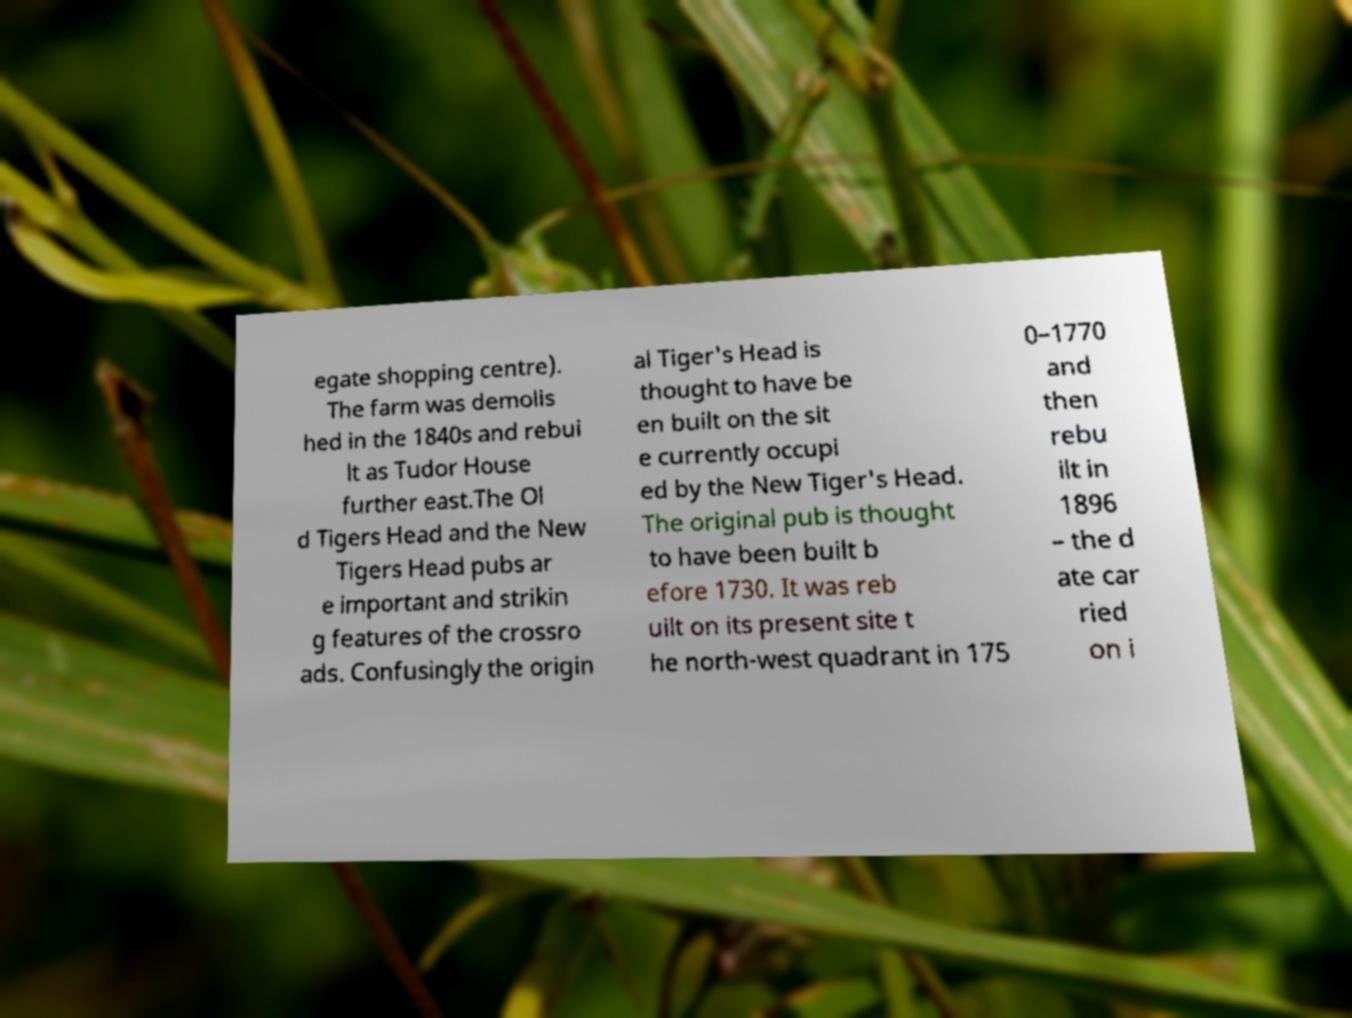There's text embedded in this image that I need extracted. Can you transcribe it verbatim? egate shopping centre). The farm was demolis hed in the 1840s and rebui lt as Tudor House further east.The Ol d Tigers Head and the New Tigers Head pubs ar e important and strikin g features of the crossro ads. Confusingly the origin al Tiger's Head is thought to have be en built on the sit e currently occupi ed by the New Tiger's Head. The original pub is thought to have been built b efore 1730. It was reb uilt on its present site t he north-west quadrant in 175 0–1770 and then rebu ilt in 1896 – the d ate car ried on i 